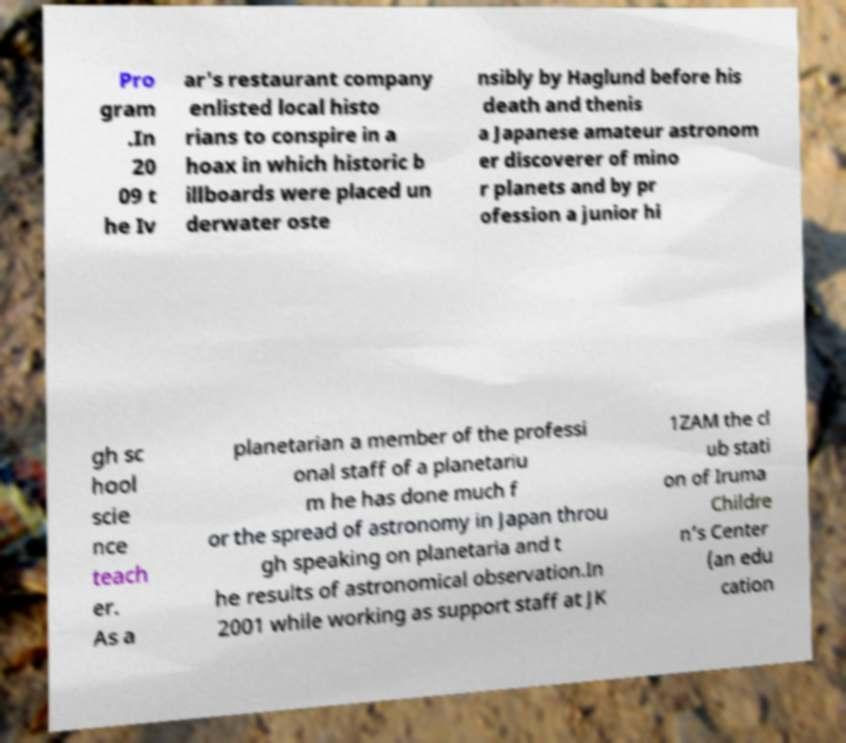Please read and relay the text visible in this image. What does it say? Pro gram .In 20 09 t he Iv ar's restaurant company enlisted local histo rians to conspire in a hoax in which historic b illboards were placed un derwater oste nsibly by Haglund before his death and thenis a Japanese amateur astronom er discoverer of mino r planets and by pr ofession a junior hi gh sc hool scie nce teach er. As a planetarian a member of the professi onal staff of a planetariu m he has done much f or the spread of astronomy in Japan throu gh speaking on planetaria and t he results of astronomical observation.In 2001 while working as support staff at JK 1ZAM the cl ub stati on of Iruma Childre n’s Center (an edu cation 